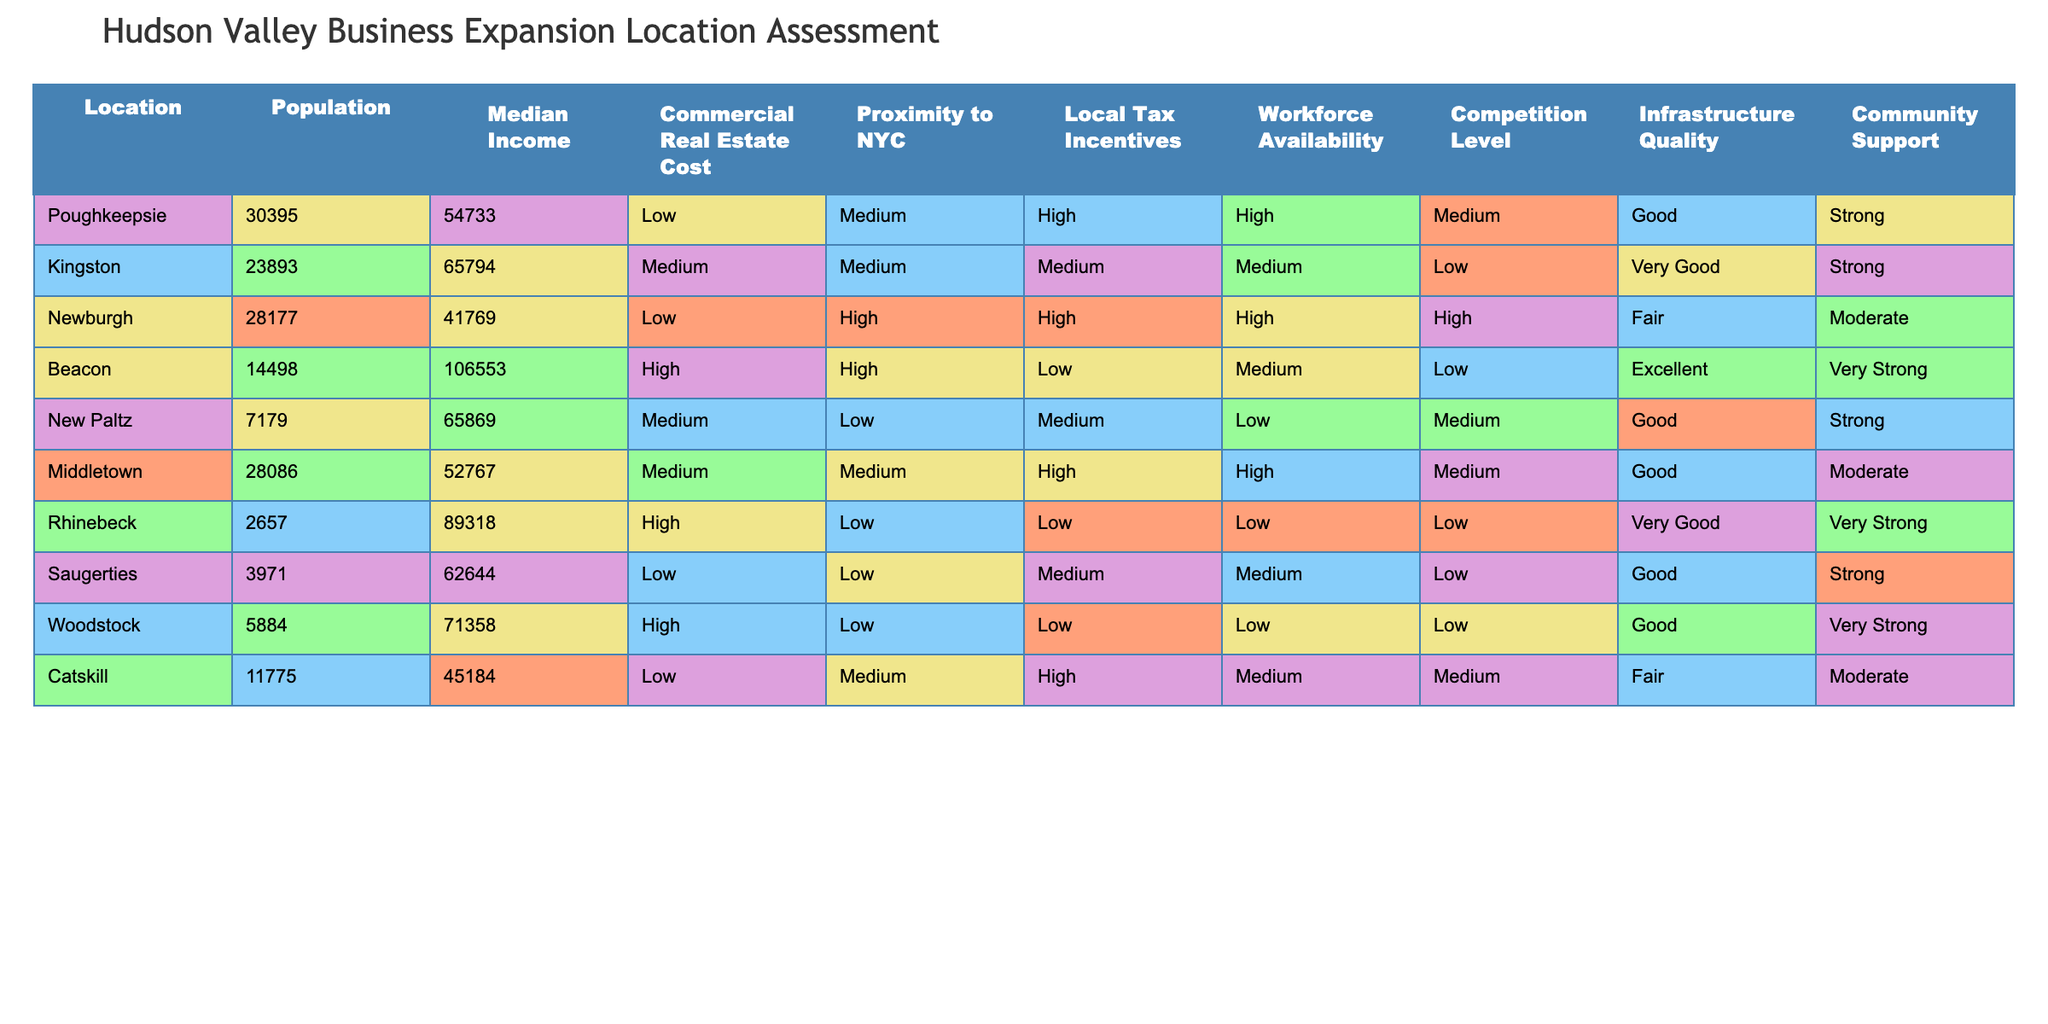What is the population of Beacon? The population of Beacon is directly listed in the table under the Population column. By locating Beacon in the table and referencing the corresponding value, we find that it is 14,498.
Answer: 14,498 Which location has the highest median income? To answer this, we need to look at the Median Income column and identify the maximum value. By comparing the values, we see that Beacon has the highest median income of $106,553.
Answer: $106,553 Is the competition level in Newburgh high? This is a yes or no question that can be answered by looking at the Competition Level column for Newburgh. The table indicates a high competition level for Newburgh.
Answer: Yes What is the average median income of the locations listed? To find the average median income, we add up all the median income values: (54,733 + 65,794 + 41,769 + 106,553 + 65,869 + 52,767 + 89,318 + 62,644 + 71,358 + 45,184) =  481,694. There are 10 locations, so we divide the total by 10: 481,694 / 10 = 48,169.4.
Answer: $48,169.4 How many locations have a Proximity to NYC classified as "High"? We can filter the Proximity to NYC column and count the instances classified as "High." There are 3 locations (Newburgh, Kingston, and Beacon) meeting this criterion.
Answer: 3 What is the total commercial real estate cost level for all locations? The Commercial Real Estate Cost categories are Low, Medium, and High. To classify them numerically, we assign values: Low = 1, Medium = 2, and High = 3. Adding up the numerical values based on the locations: (2 + 1 + 1 + 3 + 2 + 2 + 3 + 1 + 3 + 1) gives us 19. Dividing by the total number of locations (10) gives an average cost of 1.9 per location, indicating a tendency toward lower costs.
Answer: 19 Is there local tax incentive available in Woodstock? Looking at the Local Tax Incentives column for Woodstock, it indicates low tax incentives. Hence, the answer is no.
Answer: No Which location offers the best community support? By examining the Community Support column, we see that both Beacon and Rhinebeck have the highest designation of "Very Strong". Thus, those two locations reflect the best community support levels.
Answer: Beacon, Rhinebeck 